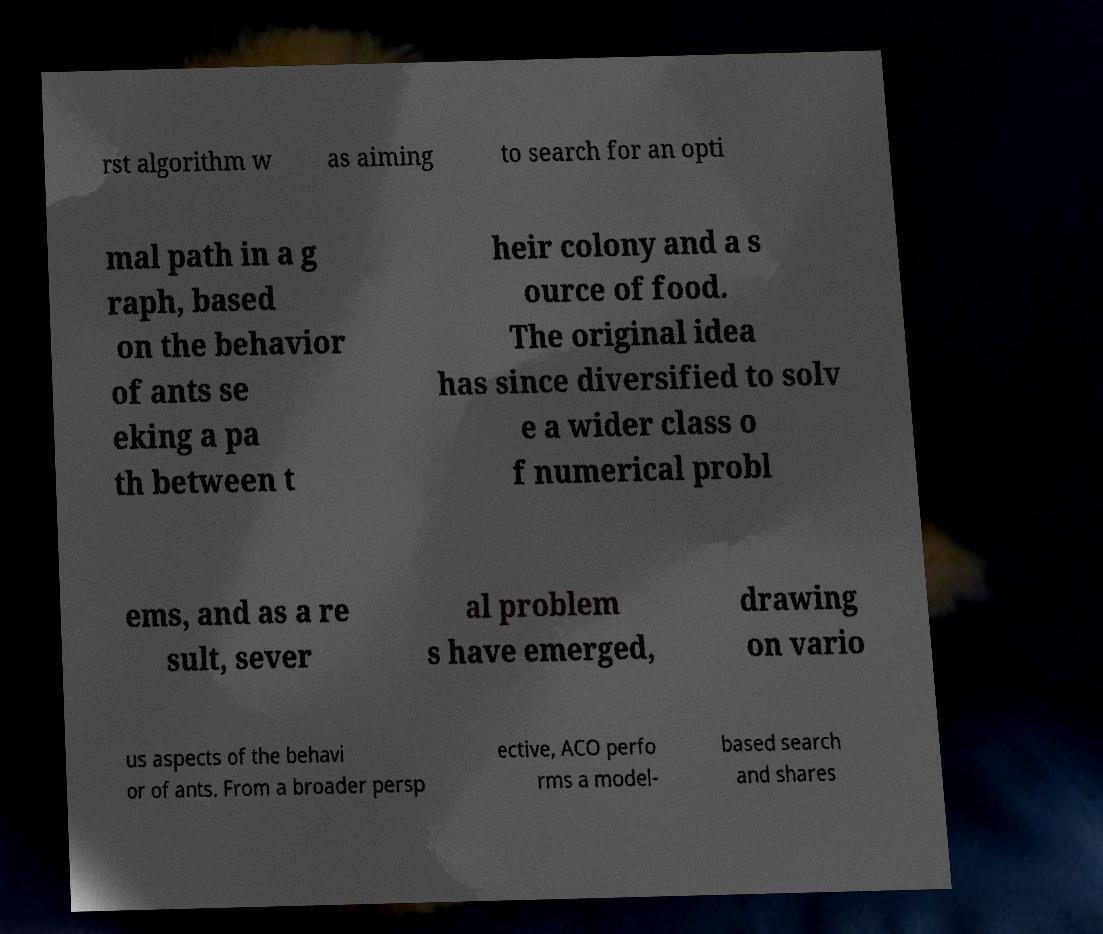Could you assist in decoding the text presented in this image and type it out clearly? rst algorithm w as aiming to search for an opti mal path in a g raph, based on the behavior of ants se eking a pa th between t heir colony and a s ource of food. The original idea has since diversified to solv e a wider class o f numerical probl ems, and as a re sult, sever al problem s have emerged, drawing on vario us aspects of the behavi or of ants. From a broader persp ective, ACO perfo rms a model- based search and shares 